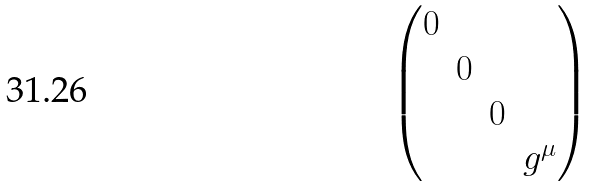<formula> <loc_0><loc_0><loc_500><loc_500>\begin{pmatrix} 0 & & & \\ & 0 & & \\ & & 0 & \\ & & & g ^ { \mu } \end{pmatrix}</formula> 